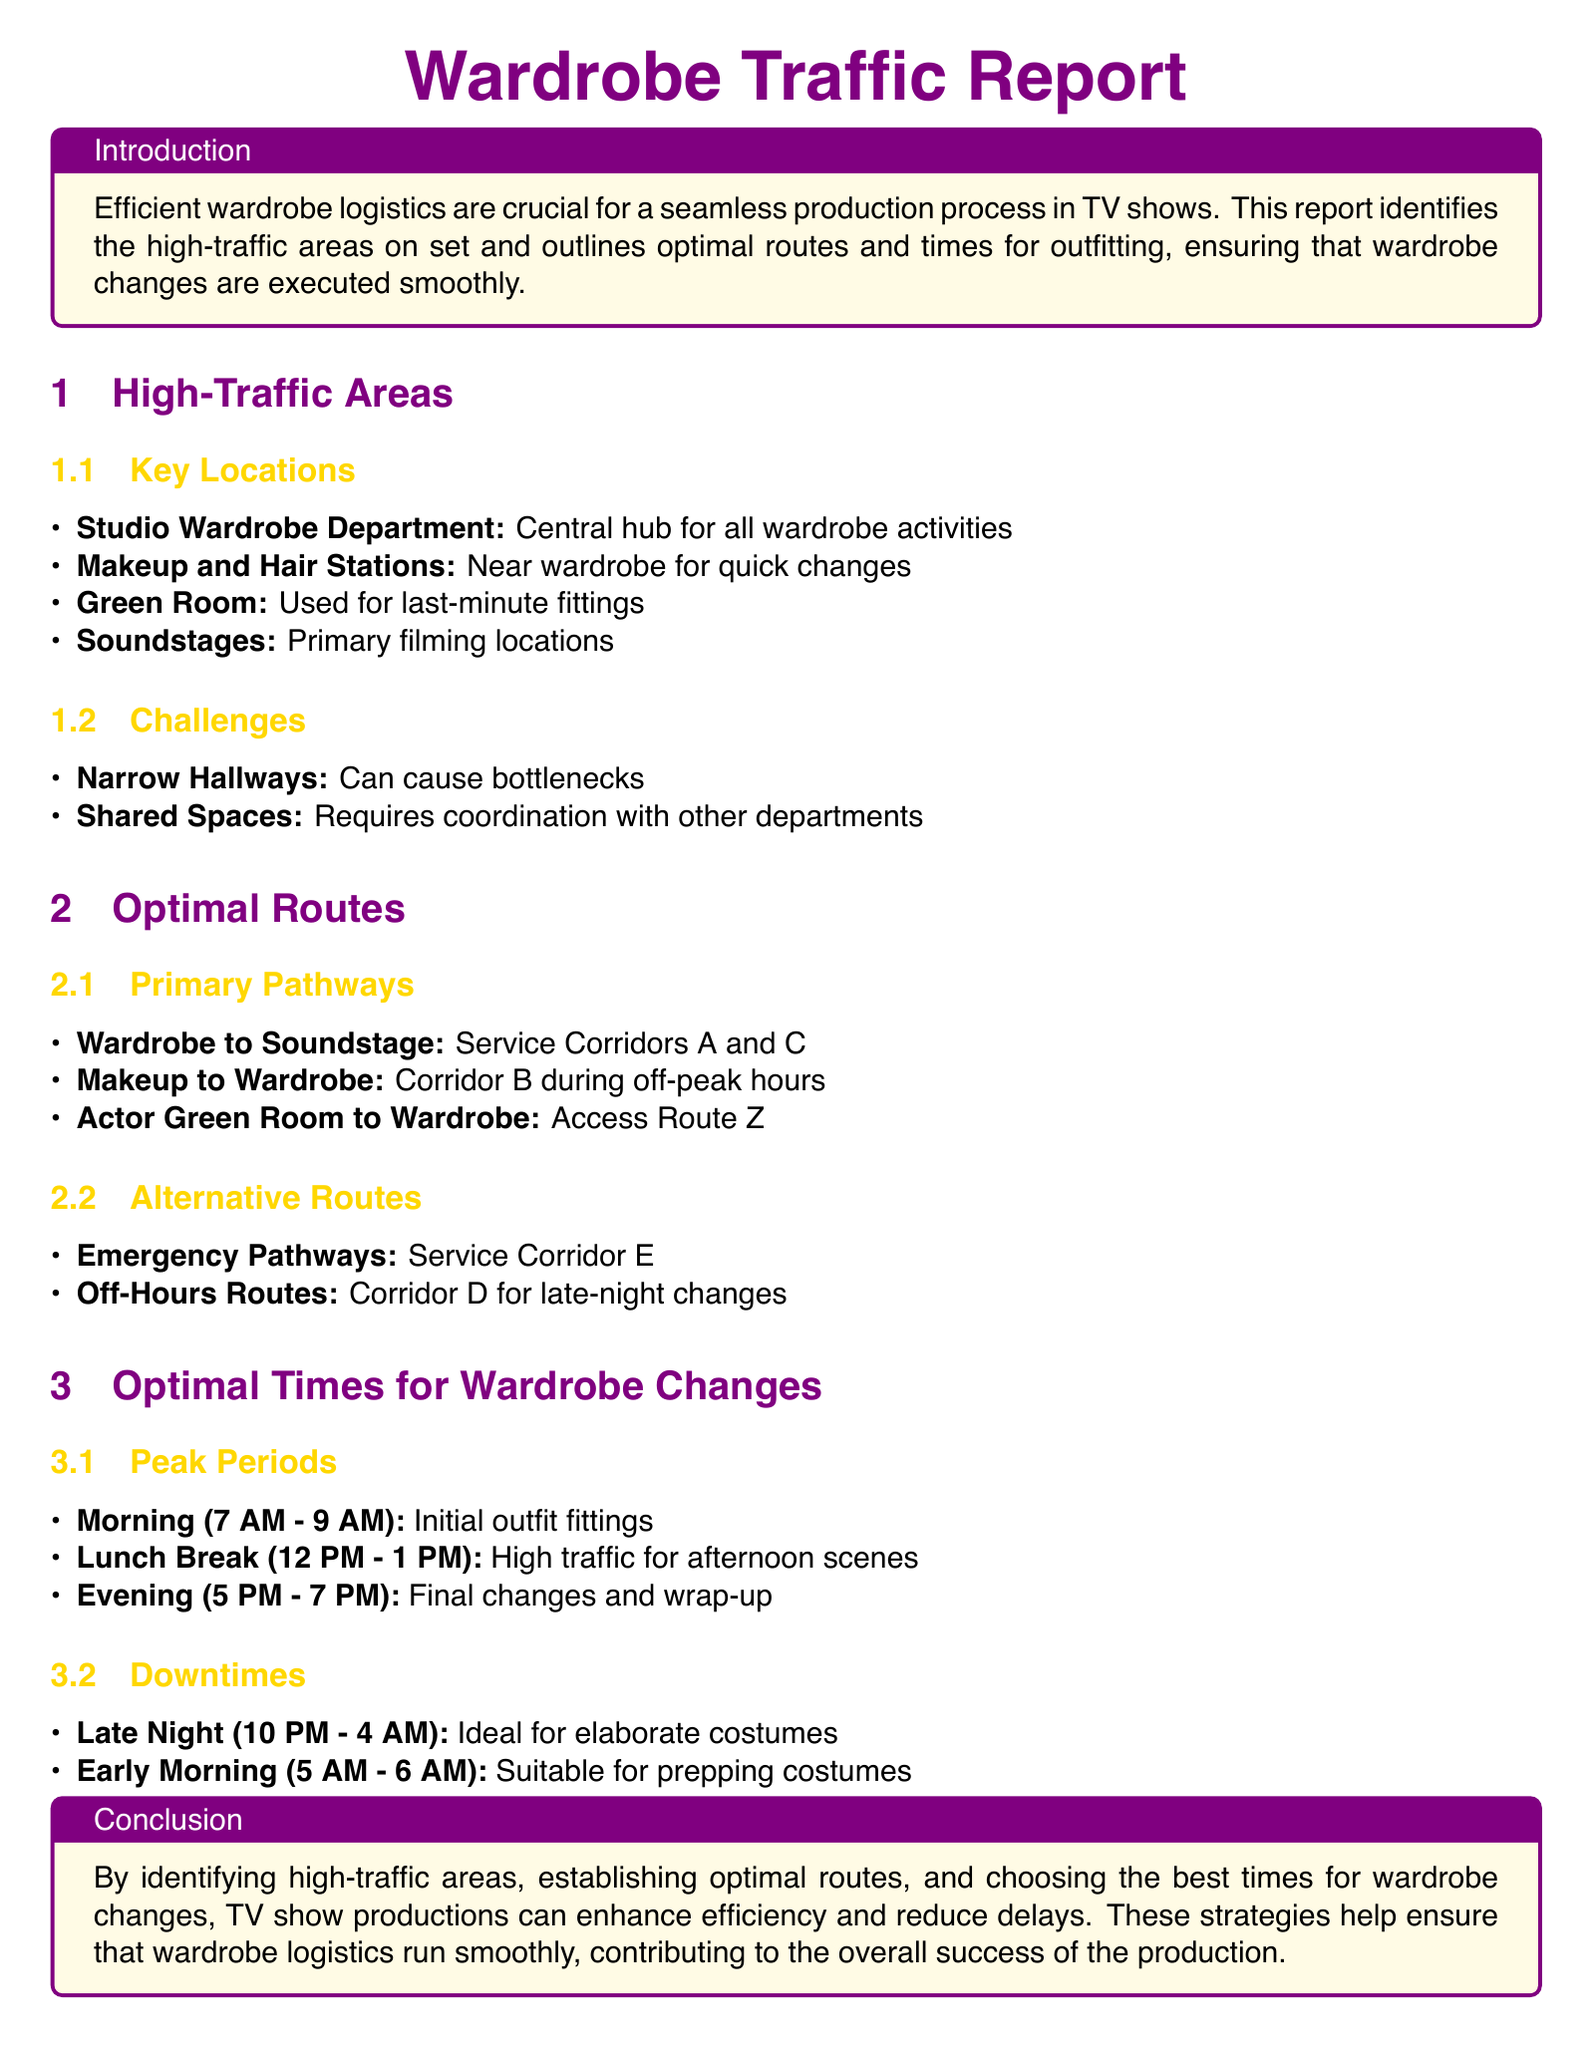What are the peak periods for wardrobe changes? The document identifies three peak periods for wardrobe changes: Morning (7 AM - 9 AM), Lunch Break (12 PM - 1 PM), and Evening (5 PM - 7 PM).
Answer: Morning (7 AM - 9 AM), Lunch Break (12 PM - 1 PM), Evening (5 PM - 7 PM) Where is the central hub for all wardrobe activities? The report states that the central hub for all wardrobe activities is the Studio Wardrobe Department.
Answer: Studio Wardrobe Department What is the alternative route for late-night changes? The document mentions that Corridor D is the alternative route for late-night changes.
Answer: Corridor D What are the challenges mentioned in the report? The challenges identified in the report include Narrow Hallways and Shared Spaces.
Answer: Narrow Hallways, Shared Spaces What time frame is considered ideal for elaborate costumes? According to the report, the ideal time frame for elaborate costumes is Late Night (10 PM - 4 AM).
Answer: Late Night (10 PM - 4 AM) 